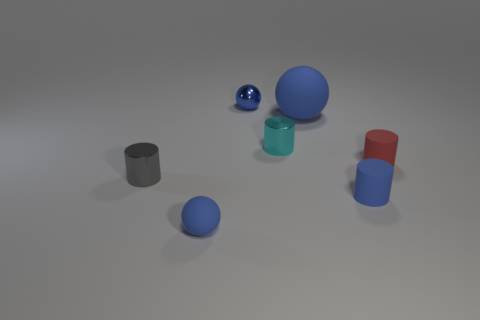What materials do the objects in the image appear to be made from? The objects in the image seem to have different materials. The spheres and the cylinder with a glossy finish suggest they might be made of a polished metal or plastic. The cubes, with their matte texture, give the impression of perhaps being made of a rubber or a non-reflective plastic material. 